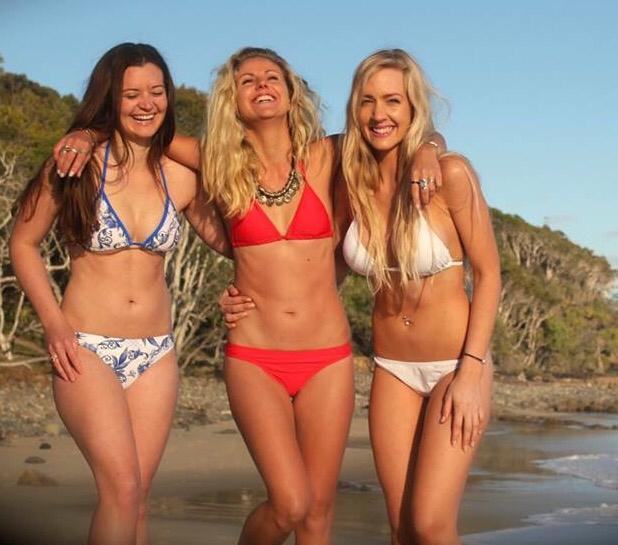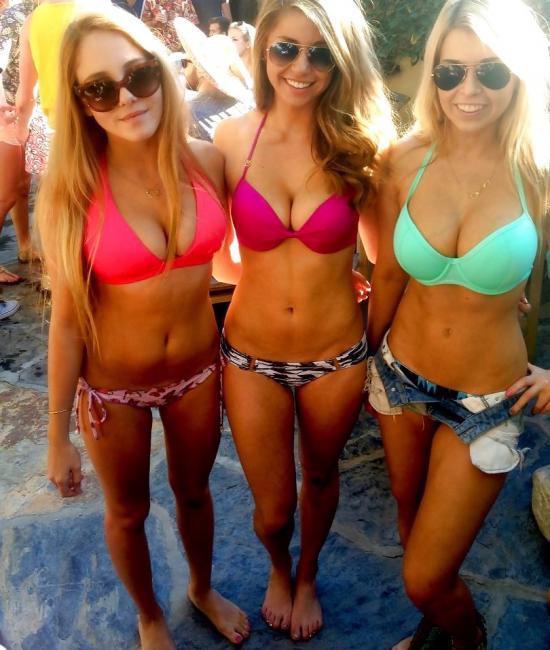The first image is the image on the left, the second image is the image on the right. Considering the images on both sides, is "One image contains at least 8 women." valid? Answer yes or no. No. The first image is the image on the left, the second image is the image on the right. Assess this claim about the two images: "All bikini models are standing, and no bikini models have their back and rear turned to the camera.". Correct or not? Answer yes or no. Yes. 